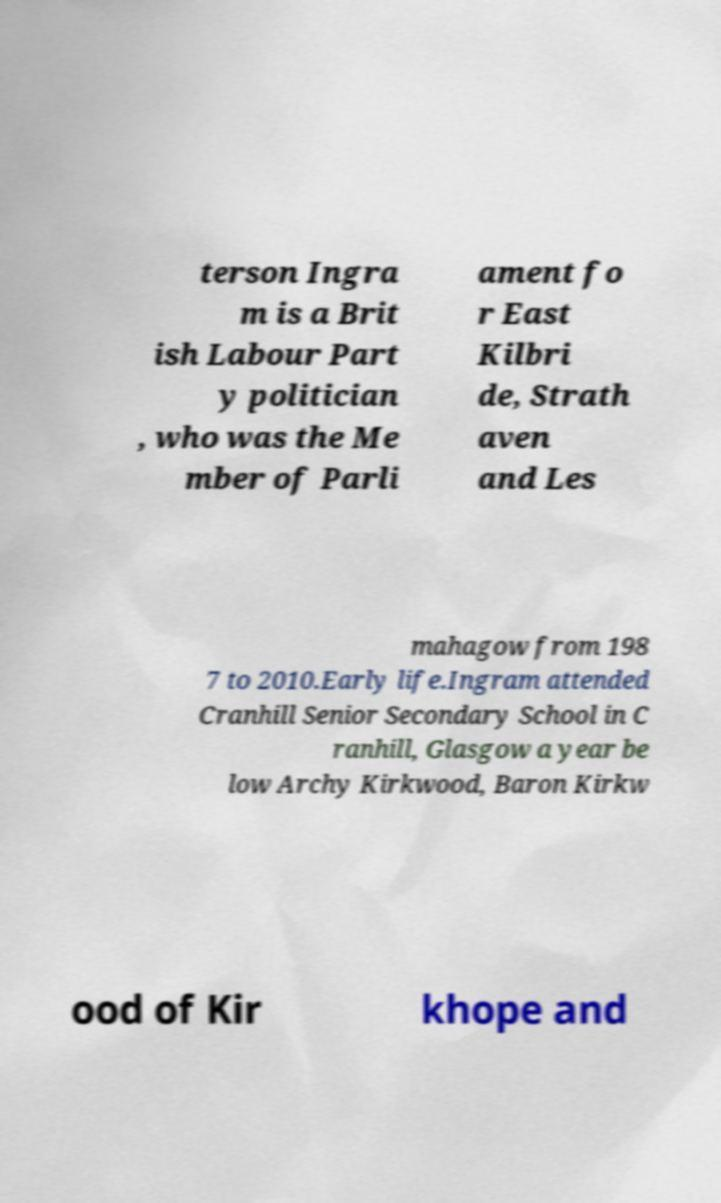Can you accurately transcribe the text from the provided image for me? terson Ingra m is a Brit ish Labour Part y politician , who was the Me mber of Parli ament fo r East Kilbri de, Strath aven and Les mahagow from 198 7 to 2010.Early life.Ingram attended Cranhill Senior Secondary School in C ranhill, Glasgow a year be low Archy Kirkwood, Baron Kirkw ood of Kir khope and 